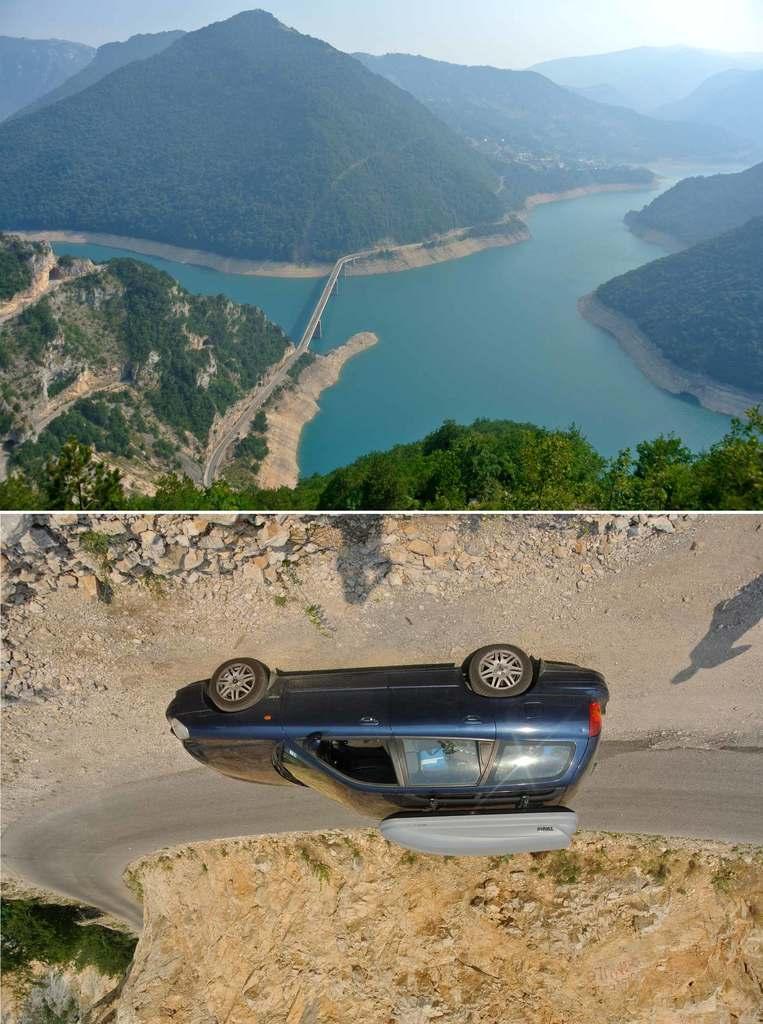Can you describe this image briefly? This is an edited image. This image is the collage of two images. The image at the top has trees, water and hills. The image at the bottom has a car which is moving on the road. Beside that, we see small stones, rocks and trees. 